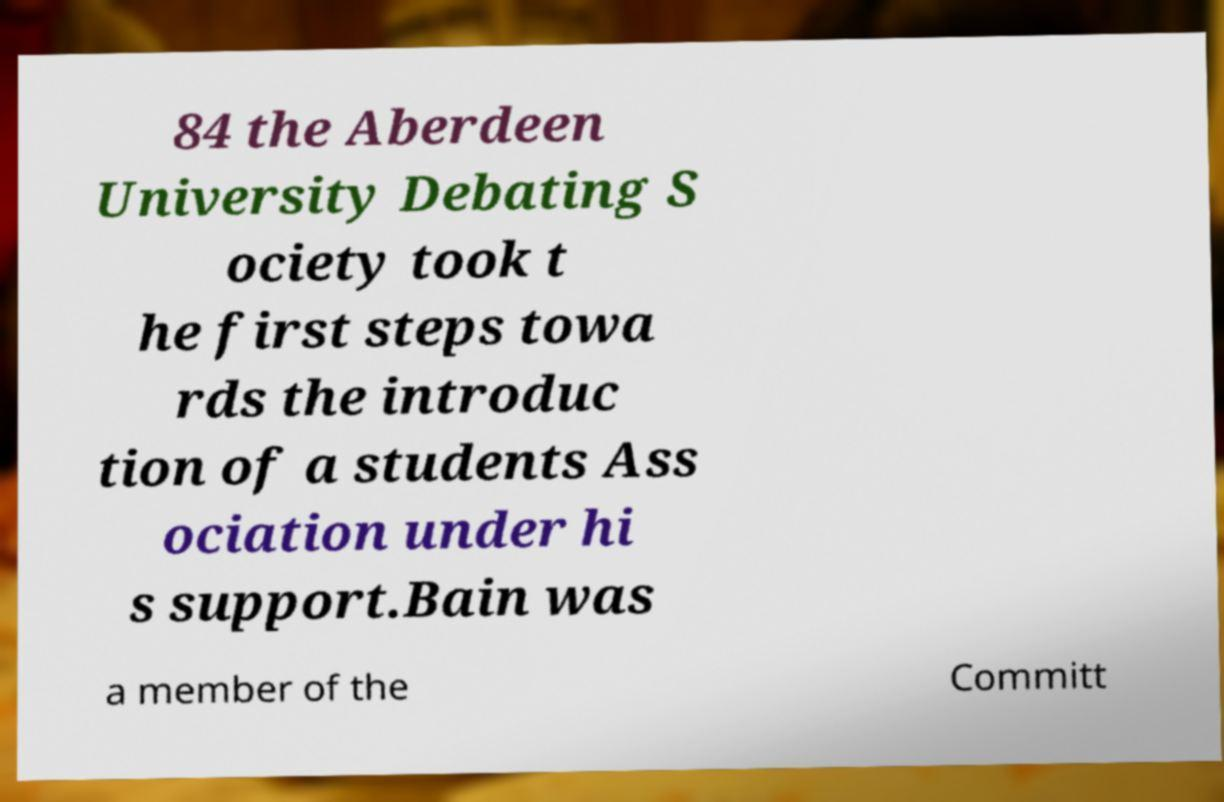Could you extract and type out the text from this image? 84 the Aberdeen University Debating S ociety took t he first steps towa rds the introduc tion of a students Ass ociation under hi s support.Bain was a member of the Committ 